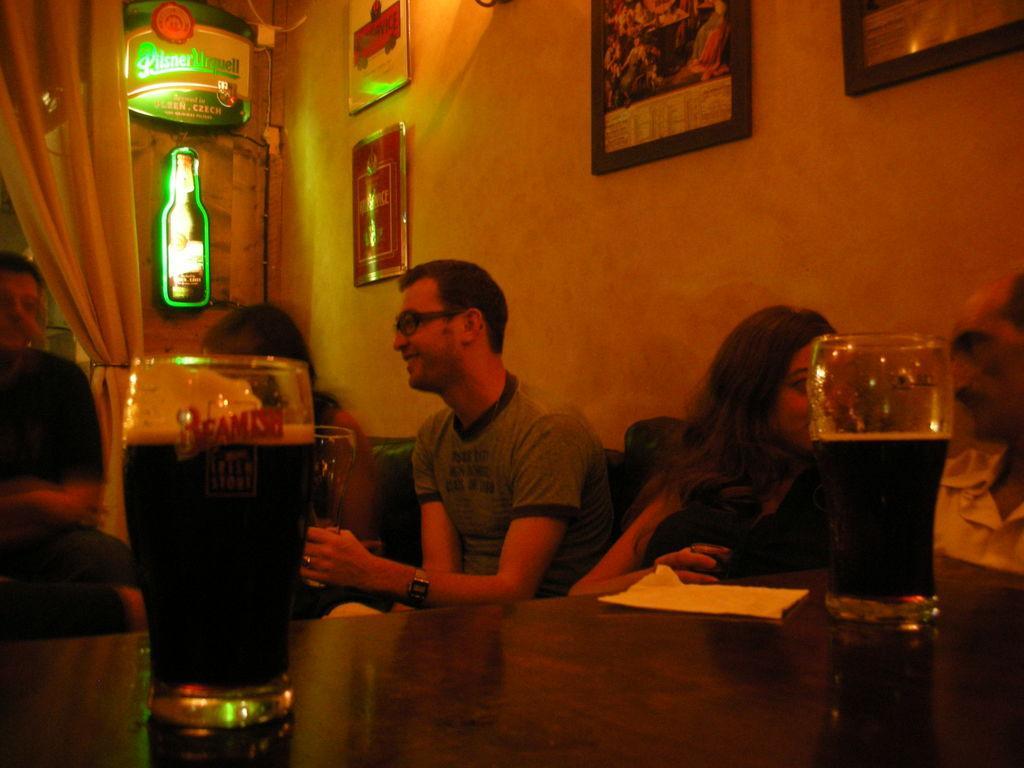Describe this image in one or two sentences. on the table there are 2 glasses filled with drinks and a paper is present on that table. behind that people are sitting, talking to each other. behind them there is a wall on which there are photo frames. at the right there are curtains. 